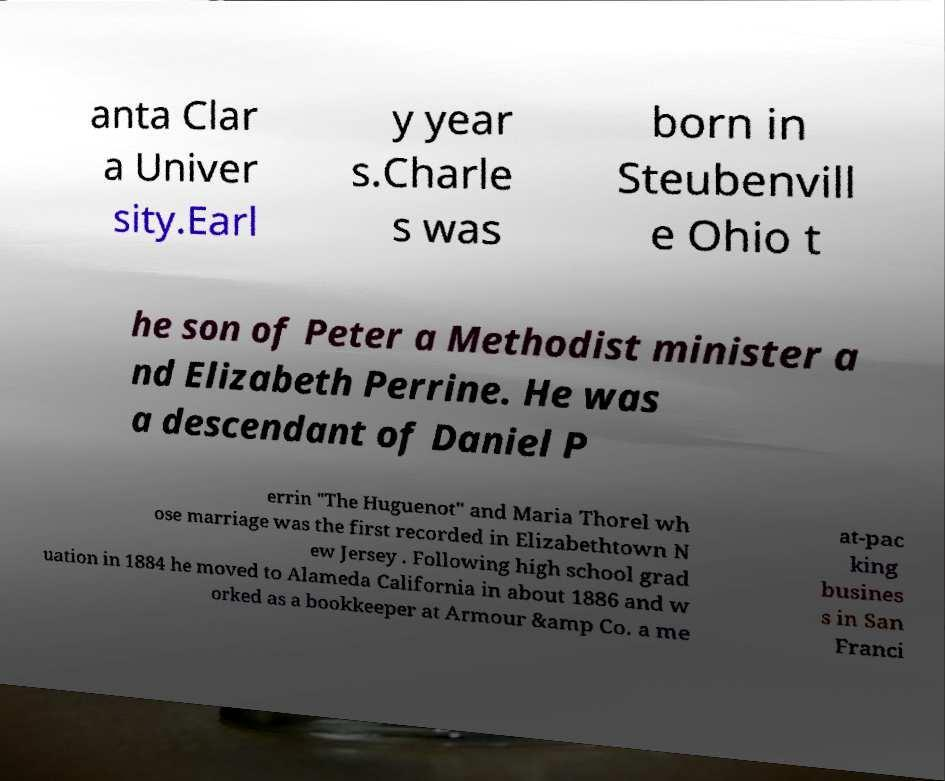What messages or text are displayed in this image? I need them in a readable, typed format. anta Clar a Univer sity.Earl y year s.Charle s was born in Steubenvill e Ohio t he son of Peter a Methodist minister a nd Elizabeth Perrine. He was a descendant of Daniel P errin "The Huguenot" and Maria Thorel wh ose marriage was the first recorded in Elizabethtown N ew Jersey . Following high school grad uation in 1884 he moved to Alameda California in about 1886 and w orked as a bookkeeper at Armour &amp Co. a me at-pac king busines s in San Franci 